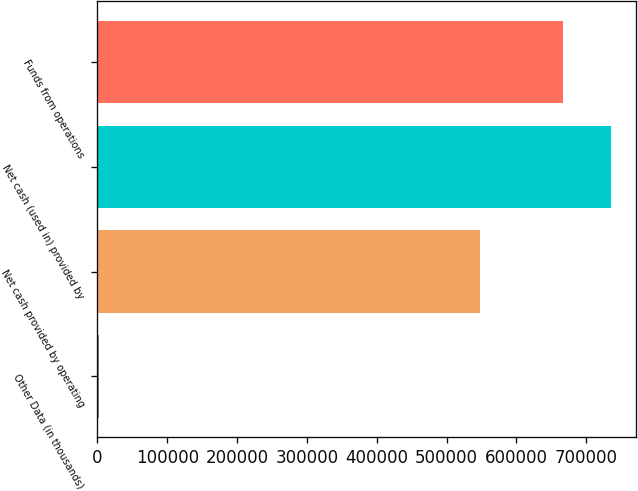Convert chart. <chart><loc_0><loc_0><loc_500><loc_500><bar_chart><fcel>Other Data (in thousands)<fcel>Net cash provided by operating<fcel>Net cash (used in) provided by<fcel>Funds from operations<nl><fcel>2017<fcel>548373<fcel>735200<fcel>667294<nl></chart> 